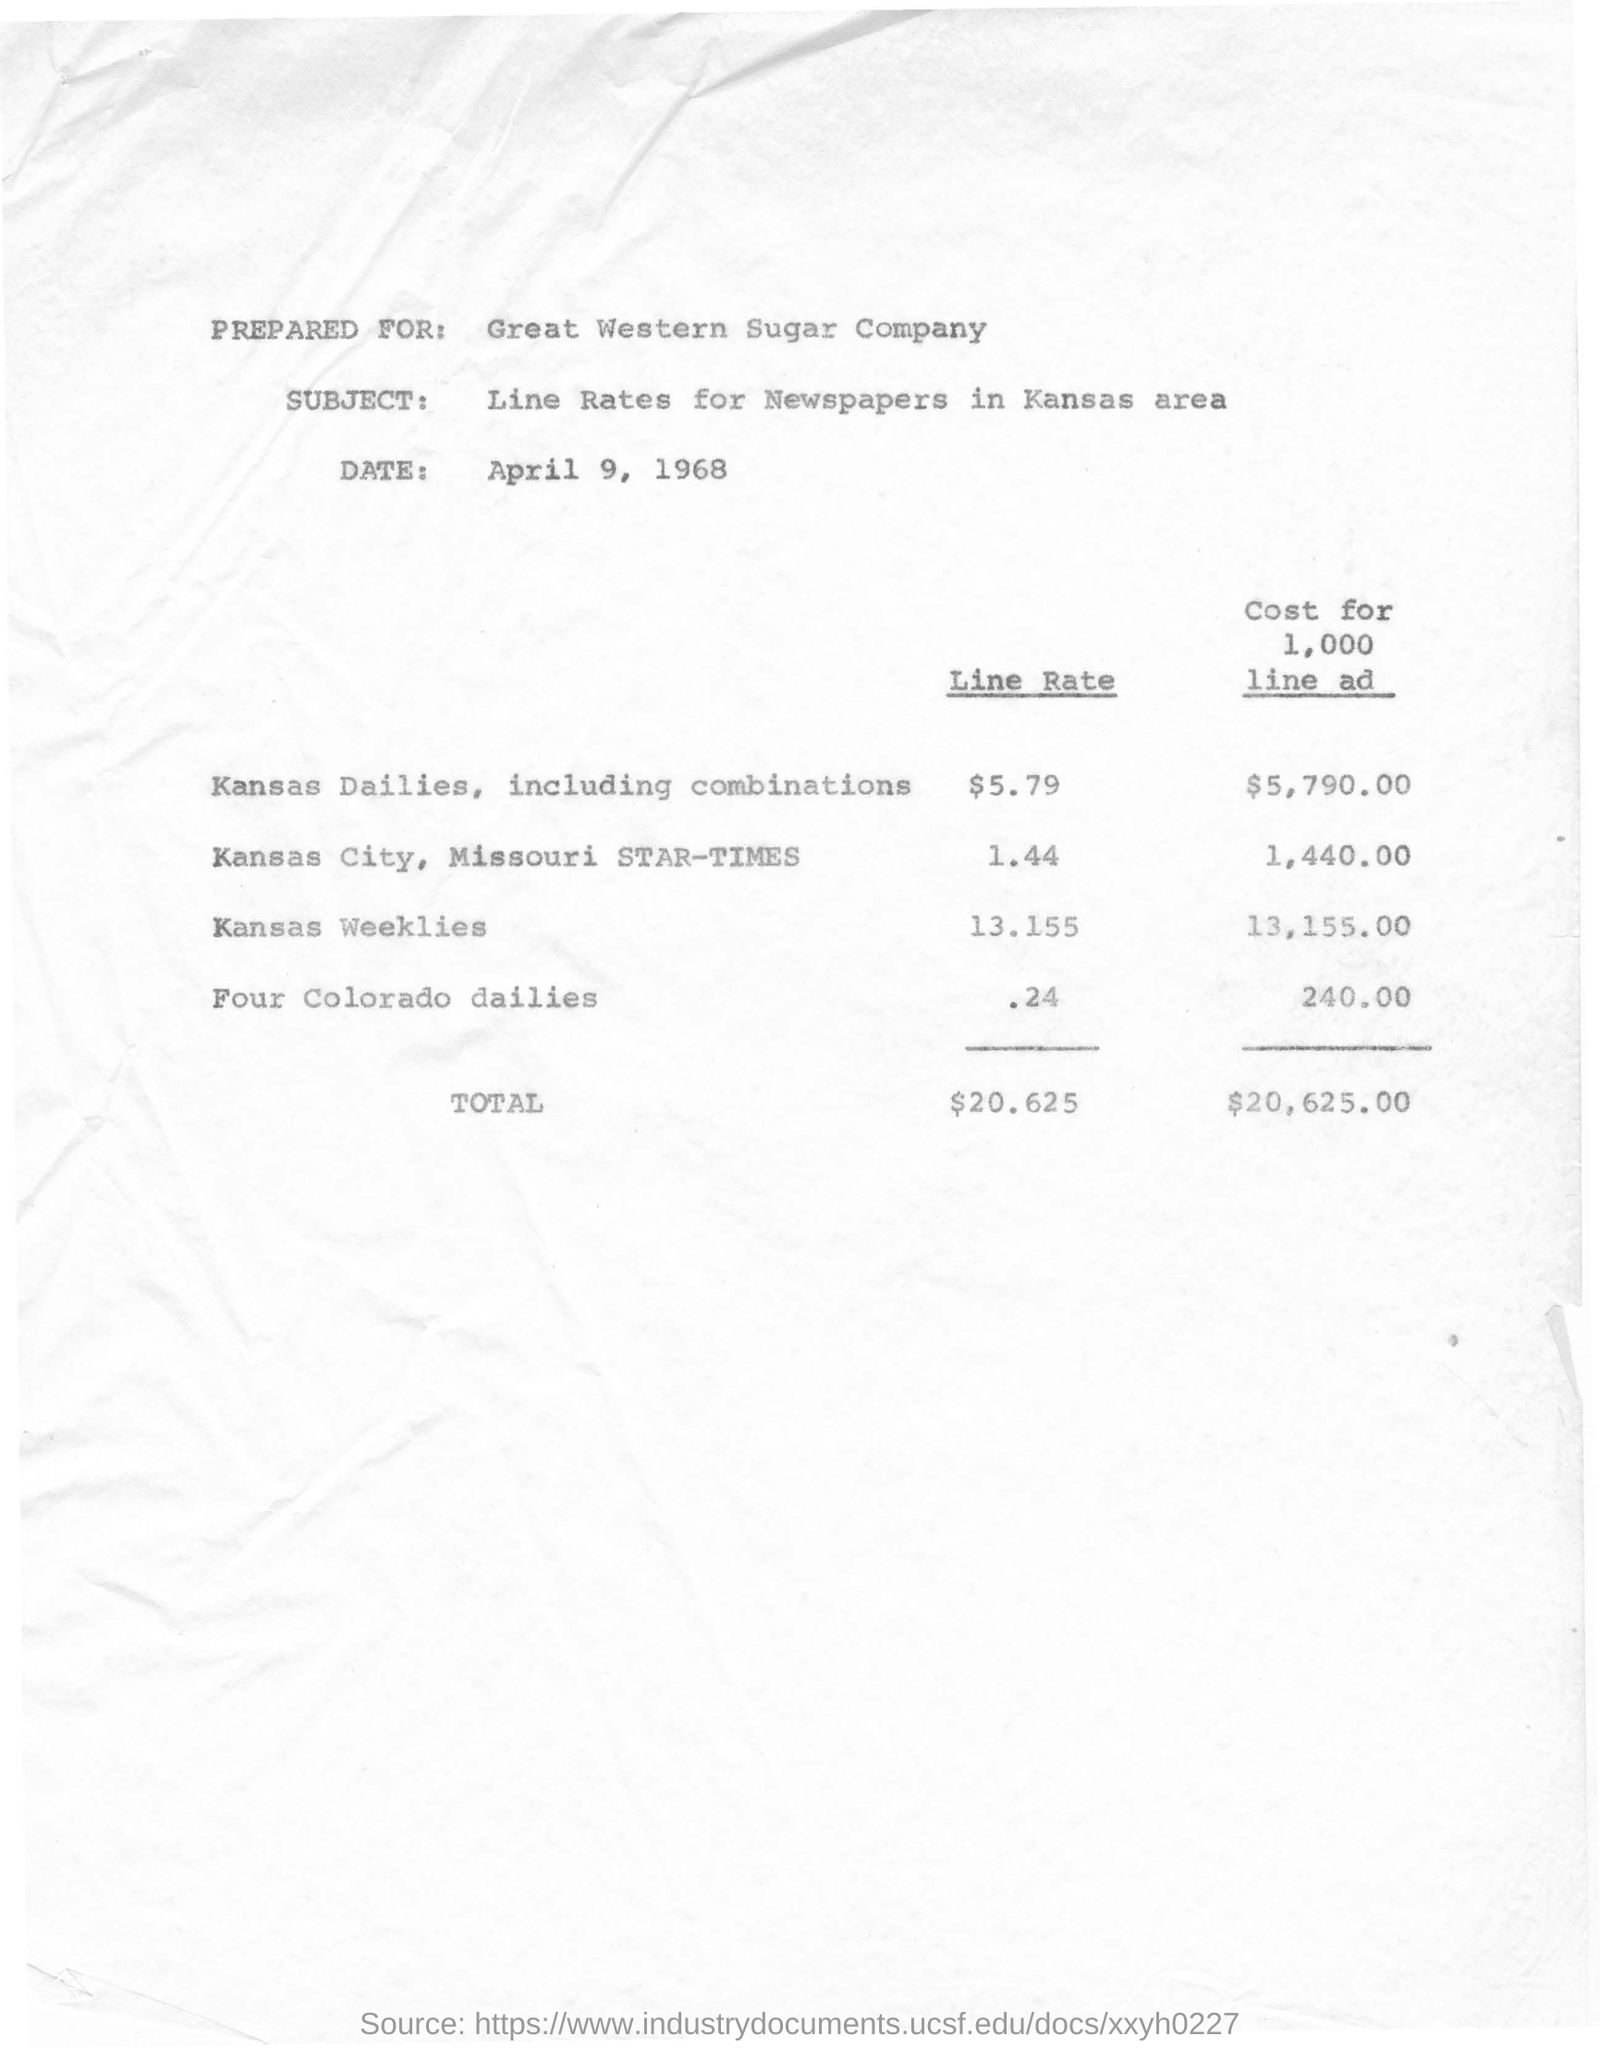What is the amount of line rate for kansas dailies,including combinations ?
Provide a short and direct response. $5.79. What is the cost for 1000 line ad in kansas city ,missouri star times ?
Provide a succinct answer. 1,440.00. What is the subject mentioned in the document?
Your response must be concise. Line Rates for Newspapers in Kansas area. For which company this information is prepared for ?
Ensure brevity in your answer.  Great western sugar company. What is the total amount for line rate ?
Keep it short and to the point. $ 20.625. What is the line rate for four colorado dailies ?
Keep it short and to the point. .24. What is the cost for 1000 line ad for kansas weeklies ?
Your answer should be compact. 13,155.00. What is the total cost for 1000 line ad ?
Make the answer very short. $ 20,625.00. 